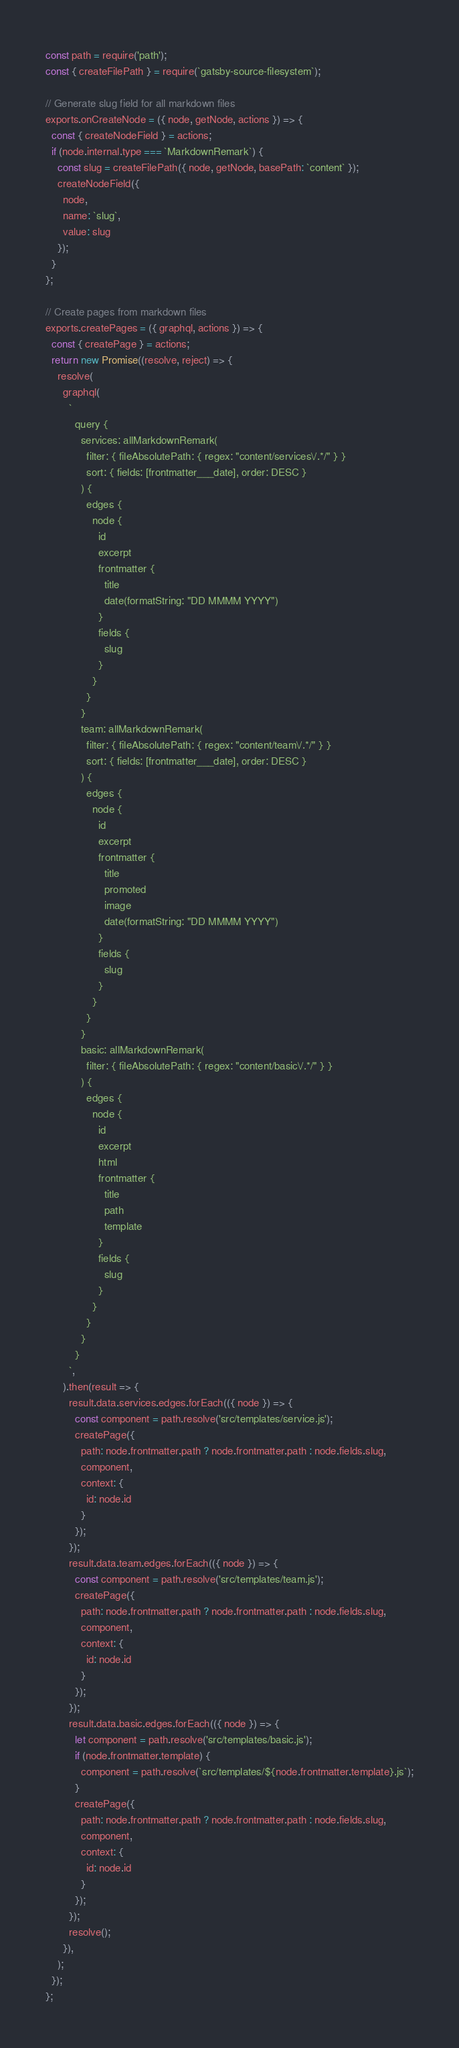<code> <loc_0><loc_0><loc_500><loc_500><_JavaScript_>const path = require('path');
const { createFilePath } = require(`gatsby-source-filesystem`);

// Generate slug field for all markdown files
exports.onCreateNode = ({ node, getNode, actions }) => {
  const { createNodeField } = actions;
  if (node.internal.type === `MarkdownRemark`) {
    const slug = createFilePath({ node, getNode, basePath: `content` });
    createNodeField({
      node,
      name: `slug`,
      value: slug
    });
  }
};

// Create pages from markdown files
exports.createPages = ({ graphql, actions }) => {
  const { createPage } = actions;
  return new Promise((resolve, reject) => {
    resolve(
      graphql(
        `
          query {
            services: allMarkdownRemark(
              filter: { fileAbsolutePath: { regex: "content/services\/.*/" } }
              sort: { fields: [frontmatter___date], order: DESC }
            ) {
              edges {
                node {
                  id
                  excerpt
                  frontmatter {
                    title
                    date(formatString: "DD MMMM YYYY")
                  }
                  fields {
                    slug
                  }
                }
              }
            }
            team: allMarkdownRemark(
              filter: { fileAbsolutePath: { regex: "content/team\/.*/" } }
              sort: { fields: [frontmatter___date], order: DESC }
            ) {
              edges {
                node {
                  id
                  excerpt
                  frontmatter {
                    title
                    promoted
                    image
                    date(formatString: "DD MMMM YYYY")
                  }
                  fields {
                    slug
                  }
                }
              }
            }
            basic: allMarkdownRemark(
              filter: { fileAbsolutePath: { regex: "content/basic\/.*/" } }
            ) {
              edges {
                node {
                  id
                  excerpt
                  html
                  frontmatter {
                    title
                    path
                    template
                  }
                  fields {
                    slug
                  }
                }
              }
            }
          }
        `,
      ).then(result => {
        result.data.services.edges.forEach(({ node }) => {
          const component = path.resolve('src/templates/service.js');
          createPage({
            path: node.frontmatter.path ? node.frontmatter.path : node.fields.slug,
            component,
            context: {
              id: node.id
            }
          });
        });
        result.data.team.edges.forEach(({ node }) => {
          const component = path.resolve('src/templates/team.js');
          createPage({
            path: node.frontmatter.path ? node.frontmatter.path : node.fields.slug,
            component,
            context: {
              id: node.id
            }
          });
        });
        result.data.basic.edges.forEach(({ node }) => {
          let component = path.resolve('src/templates/basic.js');
          if (node.frontmatter.template) {
            component = path.resolve(`src/templates/${node.frontmatter.template}.js`);
          }
          createPage({
            path: node.frontmatter.path ? node.frontmatter.path : node.fields.slug,
            component,
            context: {
              id: node.id
            }
          });
        });
        resolve();
      }),
    );
  });
};
</code> 